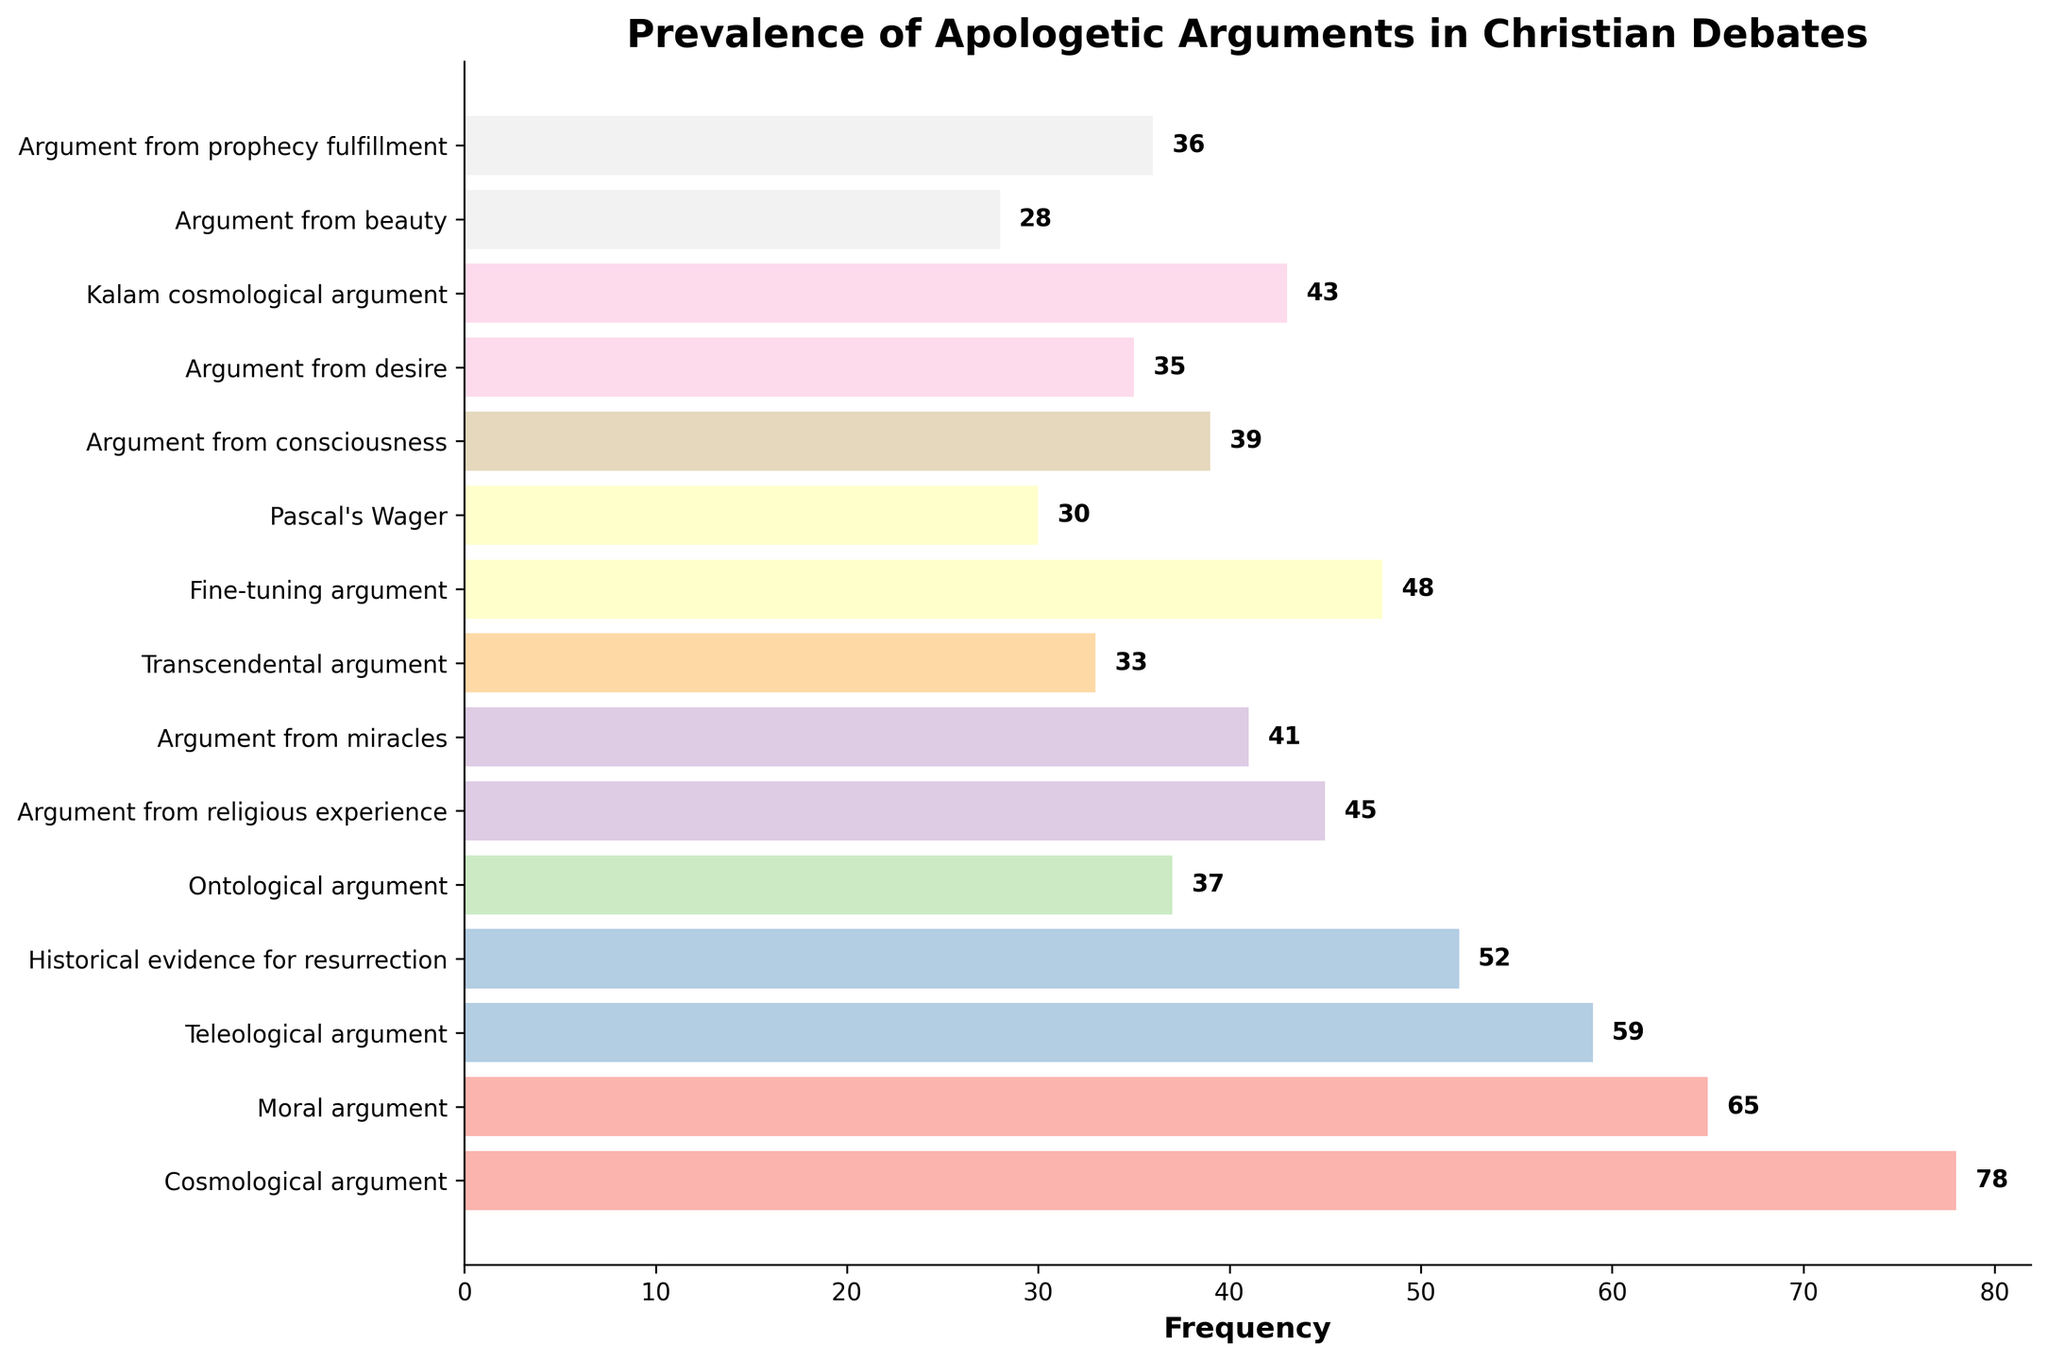Which argument has the highest frequency? The Cosmological argument has the highest bar, reaching a frequency of 78.
Answer: Cosmological argument Which argument has the lowest frequency? The Argument from beauty has the shortest bar with a frequency of 28.
Answer: Argument from beauty What is the combined frequency of the top three arguments? The top three arguments are the Cosmological argument (78), the Moral argument (65), and the Teleological argument (59). Adding them: 78 + 65 + 59 = 202.
Answer: 202 Which arguments have a frequency higher than 50? The arguments with frequencies above 50 are the Cosmological argument (78), the Moral argument (65), the Teleological argument (59), and the Historical evidence for resurrection (52).
Answer: Cosmological argument, Moral argument, Teleological argument, Historical evidence for resurrection How many arguments have a frequency between 30 and 50? The arguments with frequencies between 30 and 50 are Argument from religious experience (45), Argument from miracles (41), Fine-tuning argument (48), Kalam cosmological argument (43), Argument from consciousness (39), Argument from desire (35), Argument from prophecy fulfillment (36), and Pascal's Wager (30). There are 8 such arguments.
Answer: 8 Is the frequency of the Moral argument greater than twice the frequency of the Argument from beauty? The frequency of the Moral argument is 65. Twice the frequency of the Argument from beauty (28) is 56. Since 65 > 56, the answer is yes.
Answer: Yes What is the difference in frequency between the Teleological argument and the Argument from miracles? The frequency of the Teleological argument is 59, and the Argument from miracles is 41. The difference is 59 - 41 = 18.
Answer: 18 Which argument is directly below the Cosmological argument in frequency? The argument directly below the Cosmological argument is the Moral argument which has a frequency of 65.
Answer: Moral argument What is the average frequency of all arguments? Sum all frequencies: 78 + 65 + 59 + 52 + 37 + 45 + 41 + 33 + 48 + 30 + 39 + 35 + 43 + 28 + 36 = 669. There are 15 arguments, so the average frequency is 669 / 15 = 44.6.
Answer: 44.6 Compare the frequency of the Ontological argument and the Argument from consciousness. Which one is higher by how much? The Ontological argument has a frequency of 37, and the Argument from consciousness has 39. The Argument from consciousness is higher by 39 - 37 = 2.
Answer: Argument from consciousness by 2 